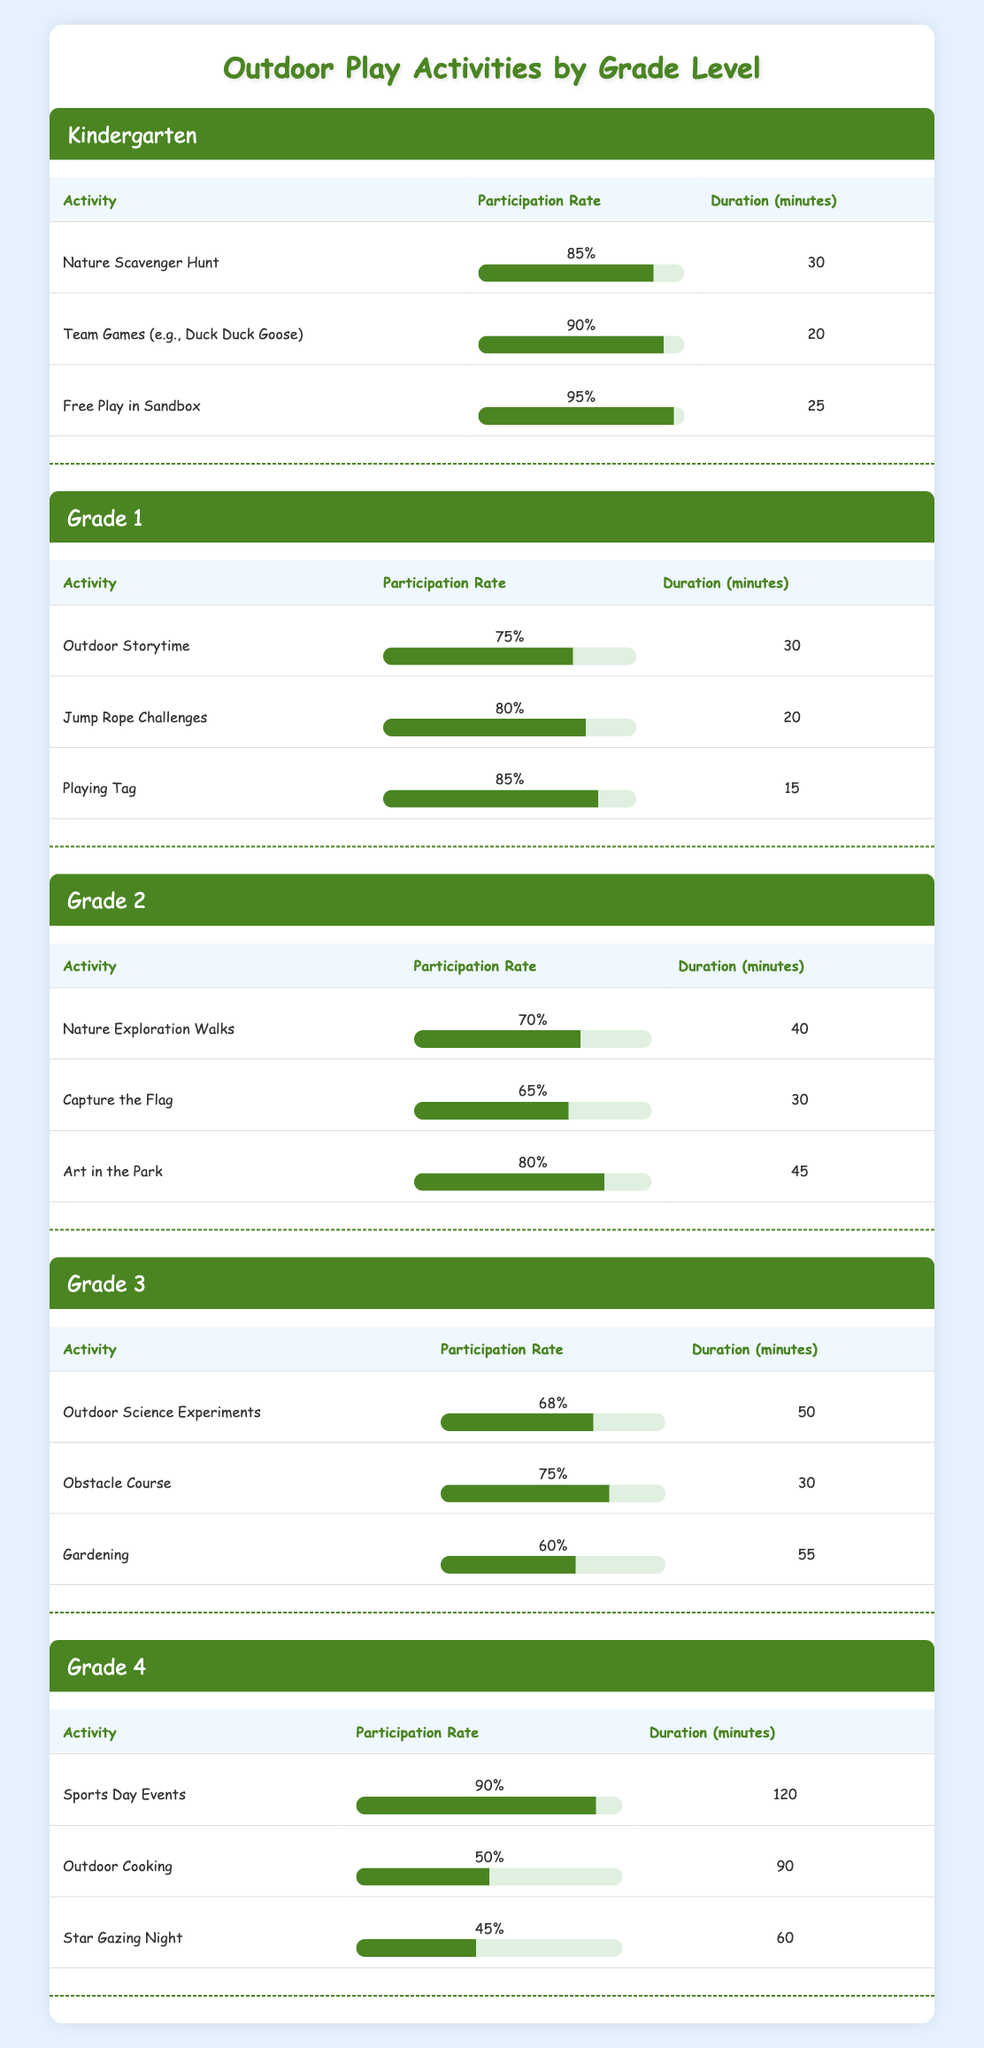What is the activity with the highest participation rate in Kindergarten? From the data in the Kindergarten section, the activities listed and their participation rates are as follows: Nature Scavenger Hunt (85%), Team Games (90%), and Free Play in Sandbox (95%). The highest rate among these is for Free Play in Sandbox at 95%.
Answer: Free Play in Sandbox Which grade level has the lowest overall participation rates in outdoor activities? To determine this, we first need to list the average participation rates for each grade: Kindergarten: (85 + 90 + 95) / 3 = 90%, Grade 1: (75 + 80 + 85) / 3 = 80%, Grade 2: (70 + 65 + 80) / 3 = 71.67%, Grade 3: (68 + 75 + 60) / 3 = 67.67%, Grade 4: (90 + 50 + 45) / 3 = 61.67%. The lowest average is for Grade 4 with 61.67%.
Answer: Grade 4 Is the participation rate for Playing Tag in Grade 1 greater than or equal to 85%? The participation rate for Playing Tag in Grade 1 is 85%, which meets the condition of being greater than or equal to 85%.
Answer: Yes What is the average duration of activities in Grade 3? The activities in Grade 3 have durations of 50 minutes, 30 minutes, and 55 minutes. Adding these values gives us a total of 135 minutes. Dividing by the number of activities (3) gives us an average duration of 135 / 3 = 45 minutes.
Answer: 45 minutes What is the participation rate difference between the highest and lowest activity in Grade 4? In Grade 4, the participation rates for the activities are: Sports Day Events (90%), Outdoor Cooking (50%), and Star Gazing Night (45%). The highest rate is 90%, and the lowest is 45%. The difference is 90% - 45% = 45%.
Answer: 45% Which activity in Grade 2 has the longest duration and what is its participation rate? In Grade 2, the activities and their durations are: Nature Exploration Walks (40 minutes), Capture the Flag (30 minutes), and Art in the Park (45 minutes). The longest duration is for Art in the Park at 45 minutes, with a participation rate of 80%.
Answer: Art in the Park, 80% 